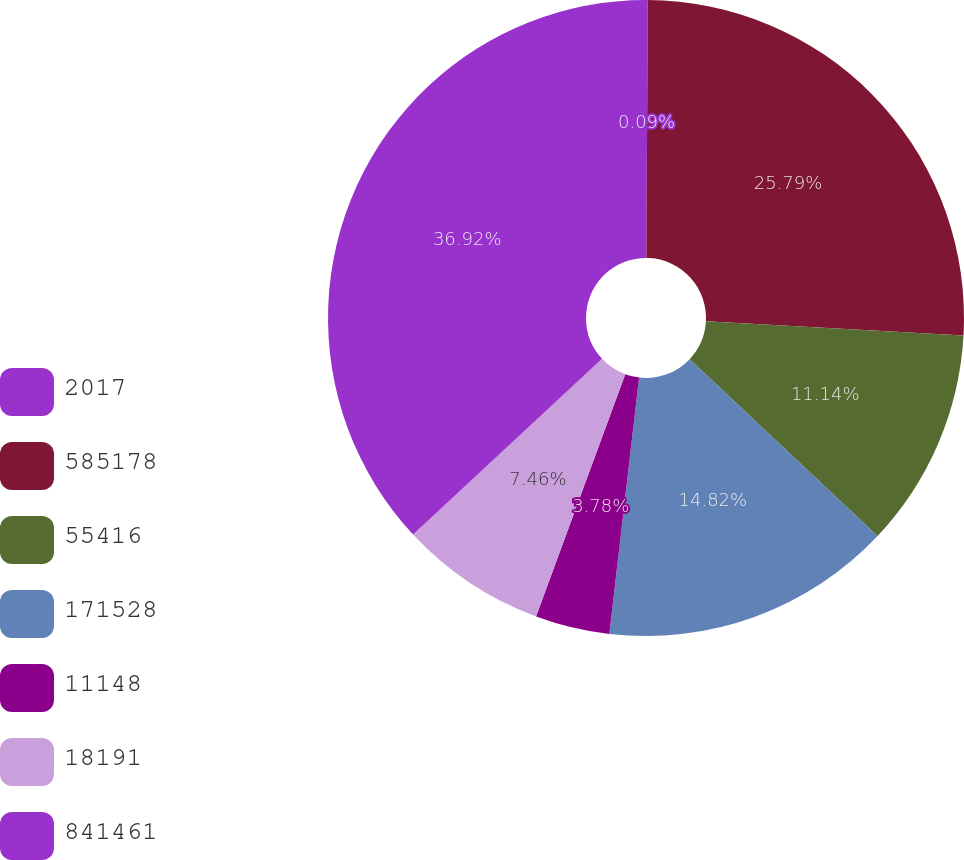Convert chart. <chart><loc_0><loc_0><loc_500><loc_500><pie_chart><fcel>2017<fcel>585178<fcel>55416<fcel>171528<fcel>11148<fcel>18191<fcel>841461<nl><fcel>0.09%<fcel>25.79%<fcel>11.14%<fcel>14.82%<fcel>3.78%<fcel>7.46%<fcel>36.92%<nl></chart> 